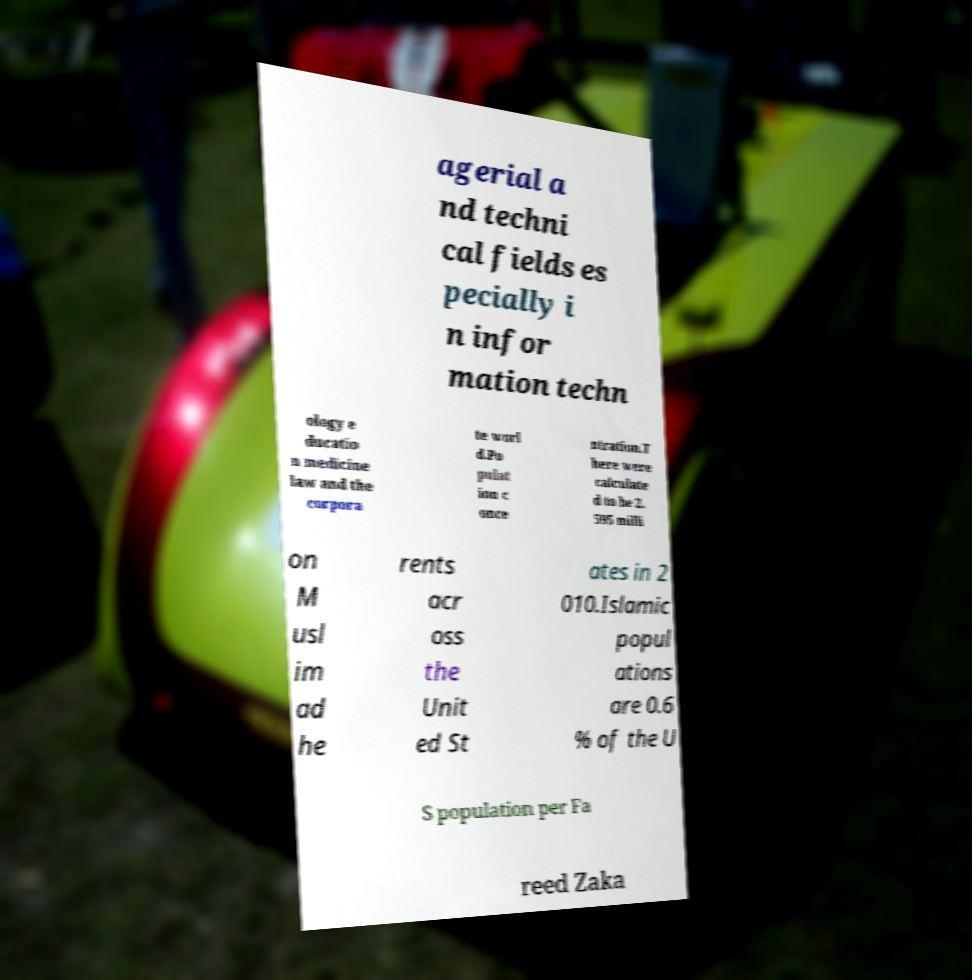Please identify and transcribe the text found in this image. agerial a nd techni cal fields es pecially i n infor mation techn ology e ducatio n medicine law and the corpora te worl d.Po pulat ion c once ntration.T here were calculate d to be 2. 595 milli on M usl im ad he rents acr oss the Unit ed St ates in 2 010.Islamic popul ations are 0.6 % of the U S population per Fa reed Zaka 